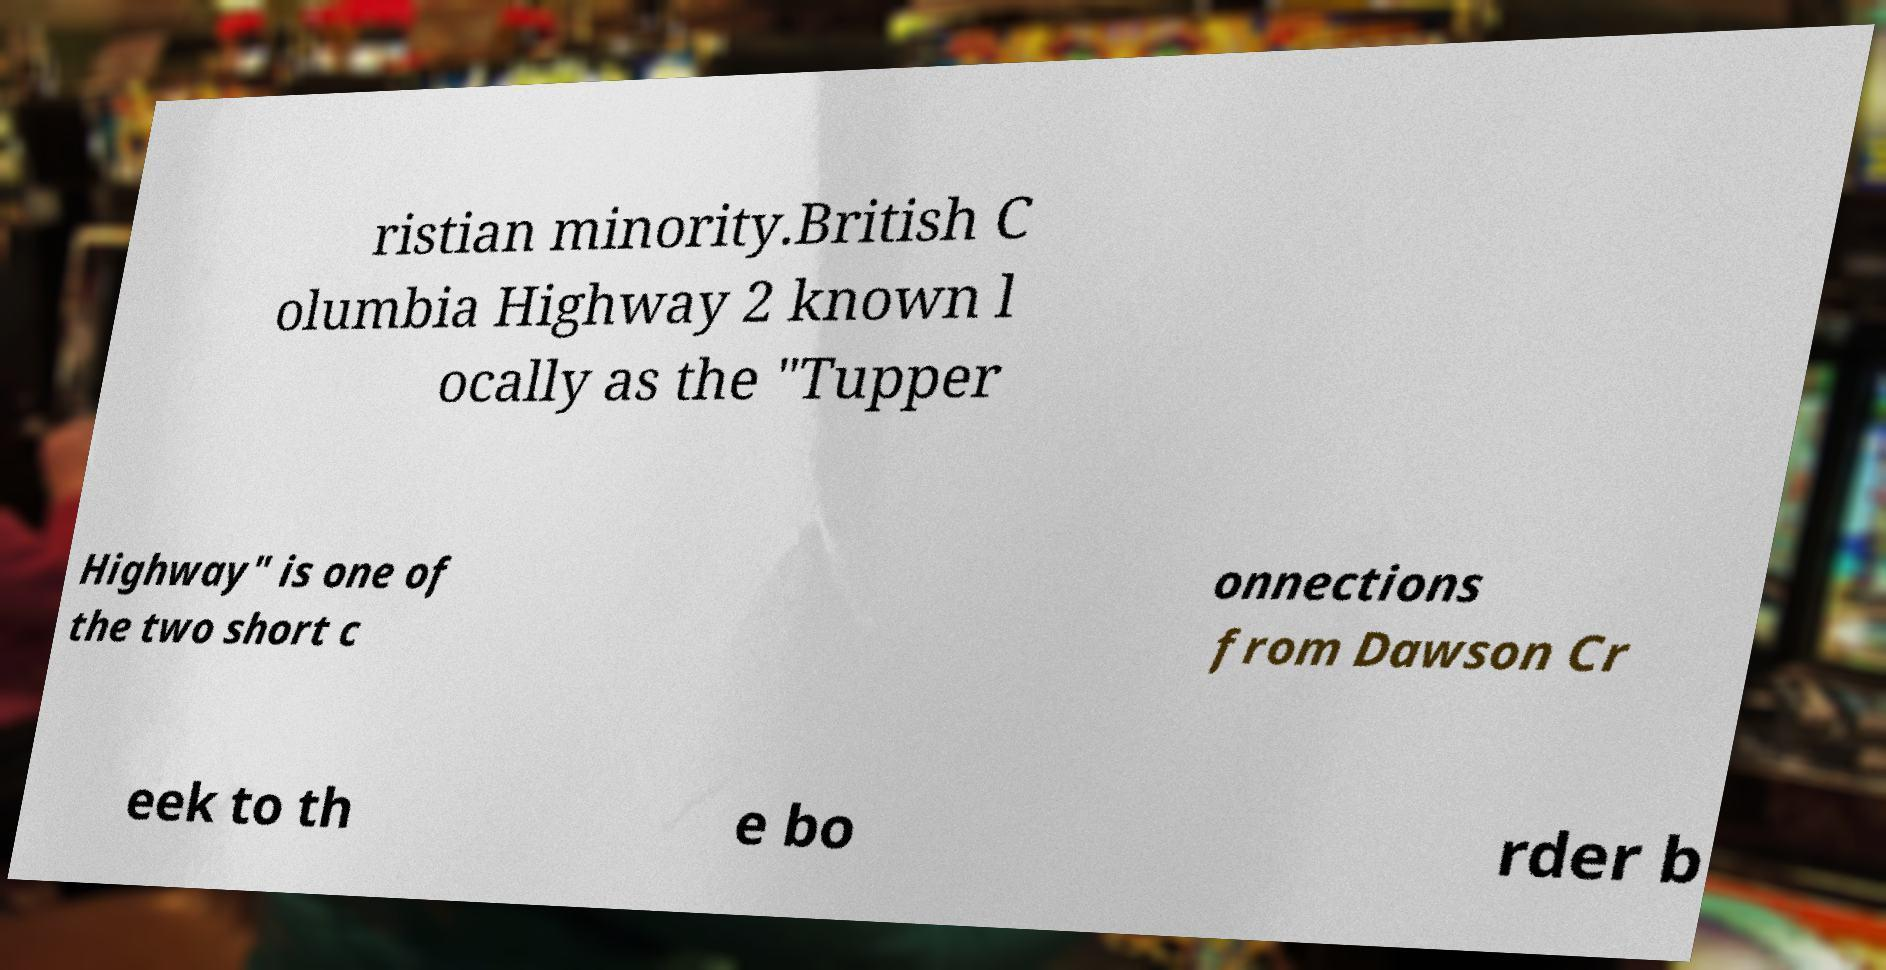What messages or text are displayed in this image? I need them in a readable, typed format. ristian minority.British C olumbia Highway 2 known l ocally as the "Tupper Highway" is one of the two short c onnections from Dawson Cr eek to th e bo rder b 